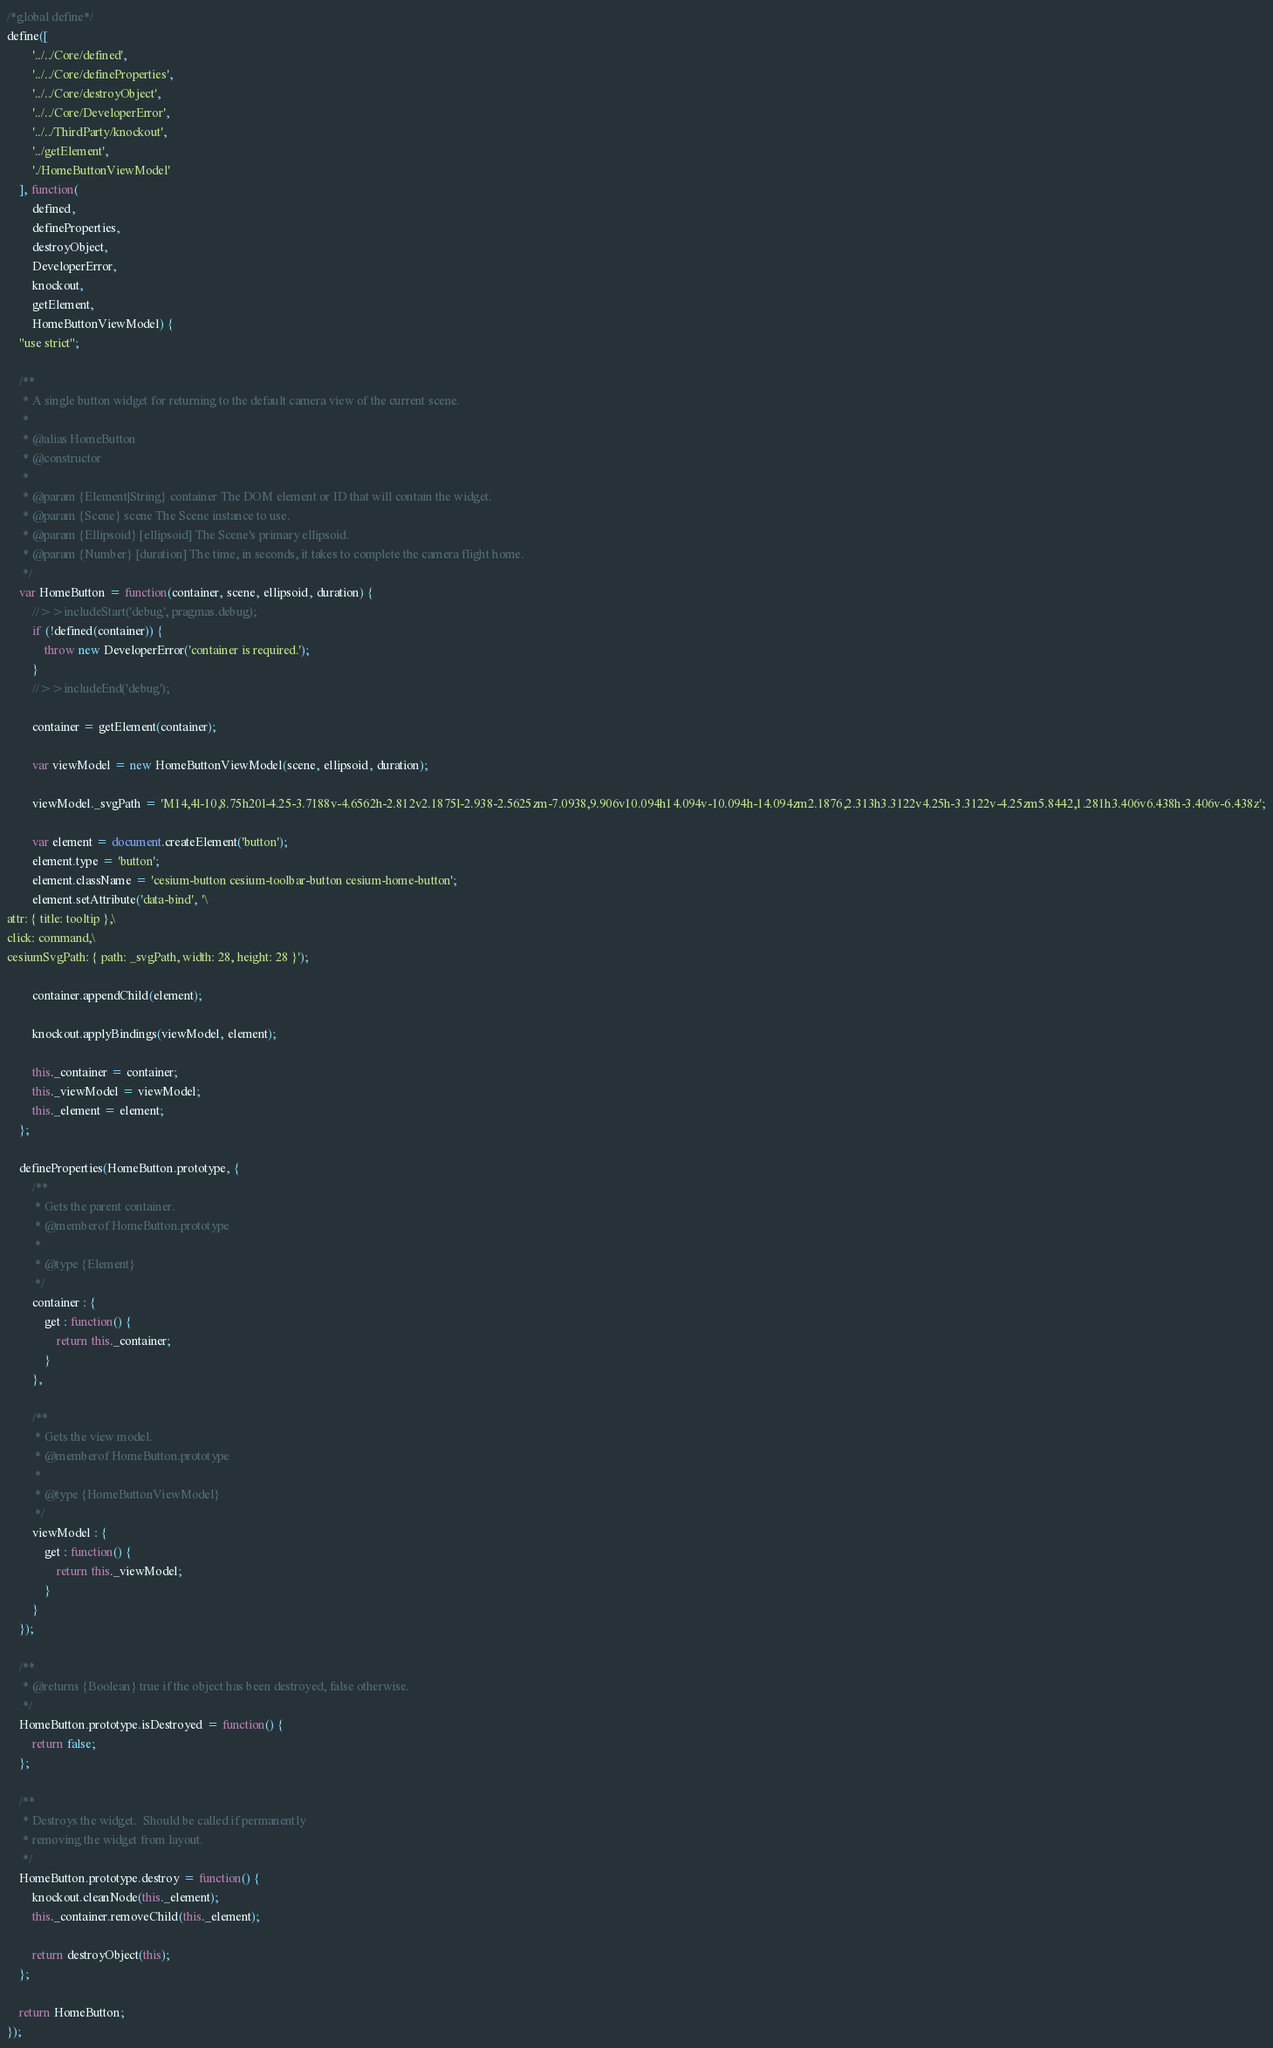Convert code to text. <code><loc_0><loc_0><loc_500><loc_500><_JavaScript_>/*global define*/
define([
        '../../Core/defined',
        '../../Core/defineProperties',
        '../../Core/destroyObject',
        '../../Core/DeveloperError',
        '../../ThirdParty/knockout',
        '../getElement',
        './HomeButtonViewModel'
    ], function(
        defined,
        defineProperties,
        destroyObject,
        DeveloperError,
        knockout,
        getElement,
        HomeButtonViewModel) {
    "use strict";

    /**
     * A single button widget for returning to the default camera view of the current scene.
     *
     * @alias HomeButton
     * @constructor
     *
     * @param {Element|String} container The DOM element or ID that will contain the widget.
     * @param {Scene} scene The Scene instance to use.
     * @param {Ellipsoid} [ellipsoid] The Scene's primary ellipsoid.
     * @param {Number} [duration] The time, in seconds, it takes to complete the camera flight home.
     */
    var HomeButton = function(container, scene, ellipsoid, duration) {
        //>>includeStart('debug', pragmas.debug);
        if (!defined(container)) {
            throw new DeveloperError('container is required.');
        }
        //>>includeEnd('debug');

        container = getElement(container);

        var viewModel = new HomeButtonViewModel(scene, ellipsoid, duration);

        viewModel._svgPath = 'M14,4l-10,8.75h20l-4.25-3.7188v-4.6562h-2.812v2.1875l-2.938-2.5625zm-7.0938,9.906v10.094h14.094v-10.094h-14.094zm2.1876,2.313h3.3122v4.25h-3.3122v-4.25zm5.8442,1.281h3.406v6.438h-3.406v-6.438z';

        var element = document.createElement('button');
        element.type = 'button';
        element.className = 'cesium-button cesium-toolbar-button cesium-home-button';
        element.setAttribute('data-bind', '\
attr: { title: tooltip },\
click: command,\
cesiumSvgPath: { path: _svgPath, width: 28, height: 28 }');

        container.appendChild(element);

        knockout.applyBindings(viewModel, element);

        this._container = container;
        this._viewModel = viewModel;
        this._element = element;
    };

    defineProperties(HomeButton.prototype, {
        /**
         * Gets the parent container.
         * @memberof HomeButton.prototype
         *
         * @type {Element}
         */
        container : {
            get : function() {
                return this._container;
            }
        },

        /**
         * Gets the view model.
         * @memberof HomeButton.prototype
         *
         * @type {HomeButtonViewModel}
         */
        viewModel : {
            get : function() {
                return this._viewModel;
            }
        }
    });

    /**
     * @returns {Boolean} true if the object has been destroyed, false otherwise.
     */
    HomeButton.prototype.isDestroyed = function() {
        return false;
    };

    /**
     * Destroys the widget.  Should be called if permanently
     * removing the widget from layout.
     */
    HomeButton.prototype.destroy = function() {
        knockout.cleanNode(this._element);
        this._container.removeChild(this._element);

        return destroyObject(this);
    };

    return HomeButton;
});
</code> 